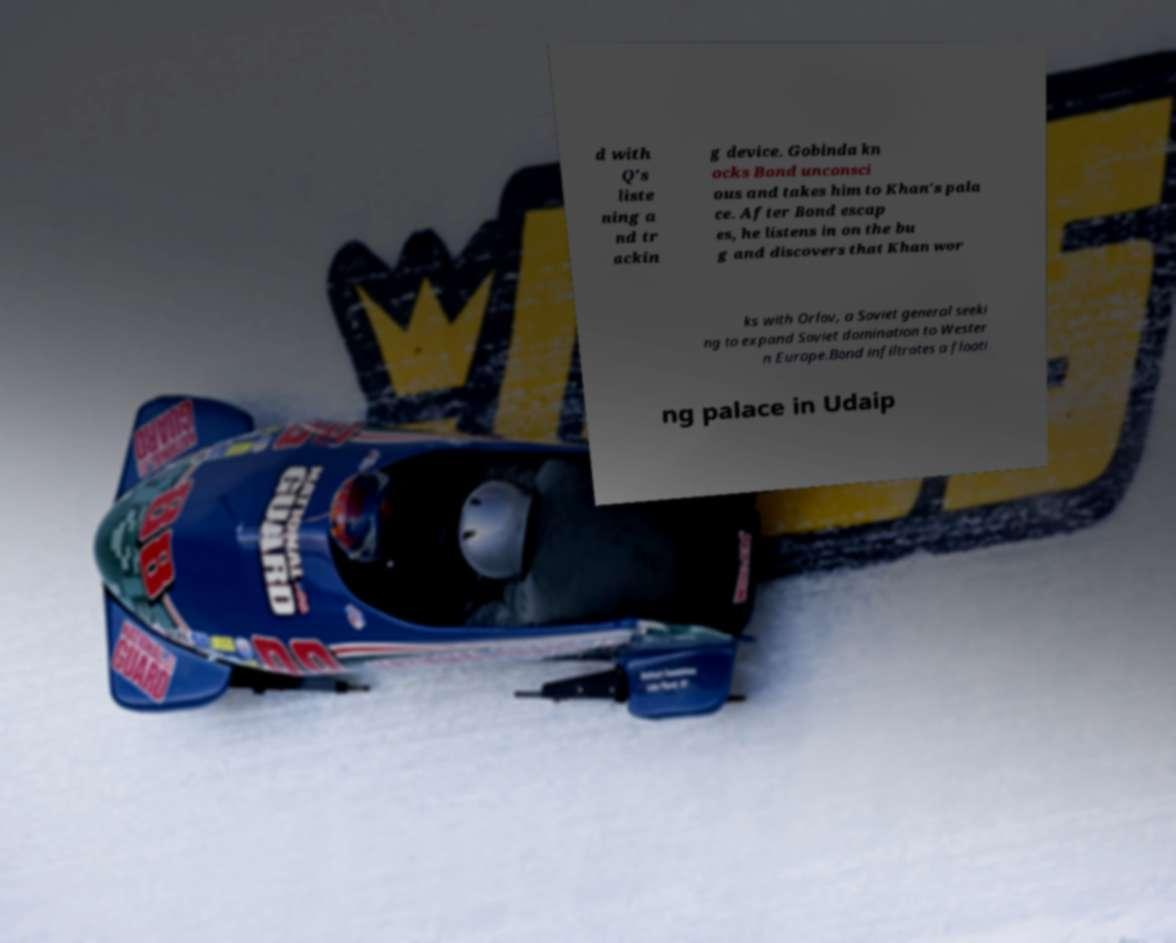Please read and relay the text visible in this image. What does it say? d with Q's liste ning a nd tr ackin g device. Gobinda kn ocks Bond unconsci ous and takes him to Khan's pala ce. After Bond escap es, he listens in on the bu g and discovers that Khan wor ks with Orlov, a Soviet general seeki ng to expand Soviet domination to Wester n Europe.Bond infiltrates a floati ng palace in Udaip 